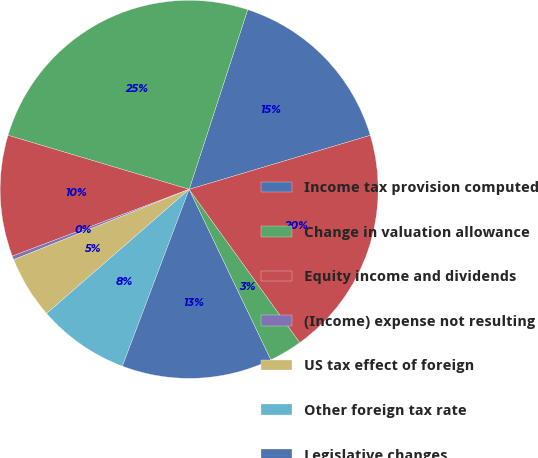Convert chart. <chart><loc_0><loc_0><loc_500><loc_500><pie_chart><fcel>Income tax provision computed<fcel>Change in valuation allowance<fcel>Equity income and dividends<fcel>(Income) expense not resulting<fcel>US tax effect of foreign<fcel>Other foreign tax rate<fcel>Legislative changes<fcel>State income taxes and other<fcel>Income tax provision (benefit)<nl><fcel>15.37%<fcel>25.4%<fcel>10.36%<fcel>0.32%<fcel>5.34%<fcel>7.85%<fcel>12.86%<fcel>2.83%<fcel>19.66%<nl></chart> 